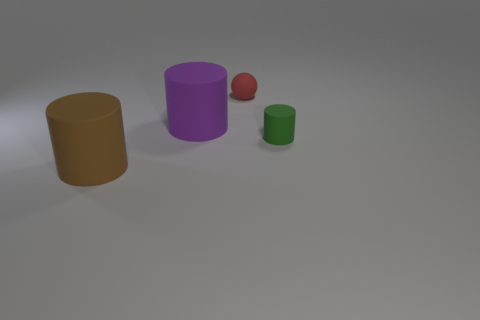Is there any other thing that is the same shape as the red matte thing?
Your response must be concise. No. What number of purple objects are big rubber objects or small balls?
Your response must be concise. 1. What number of green things have the same size as the red rubber object?
Offer a terse response. 1. Is the number of tiny red objects behind the tiny ball the same as the number of big rubber balls?
Make the answer very short. Yes. What number of rubber objects are on the right side of the big brown matte thing and in front of the small red object?
Give a very brief answer. 2. Does the rubber object that is in front of the tiny rubber cylinder have the same shape as the red rubber thing?
Your answer should be very brief. No. There is a ball that is the same size as the green matte cylinder; what is it made of?
Your response must be concise. Rubber. Are there an equal number of big brown rubber things on the right side of the purple rubber object and brown cylinders that are on the right side of the brown matte thing?
Offer a terse response. Yes. There is a cylinder that is to the right of the matte sphere that is on the right side of the brown object; what number of red balls are right of it?
Your answer should be very brief. 0. What size is the red ball that is the same material as the big brown cylinder?
Keep it short and to the point. Small. 